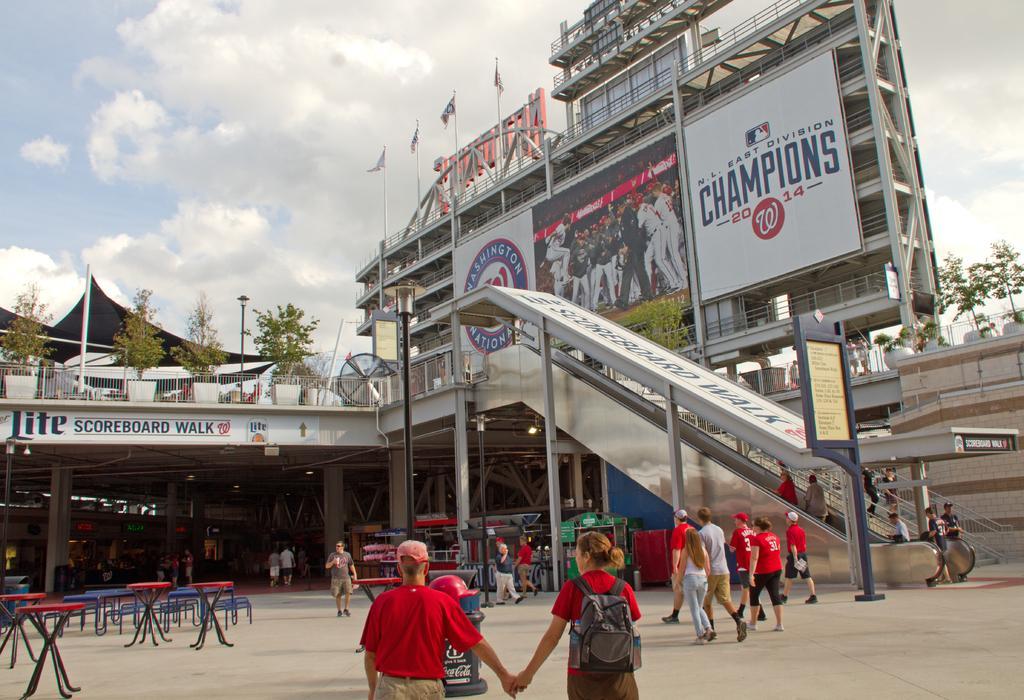How would you summarize this image in a sentence or two? In this picture we can see a group of people walking on the path and in front of the people there is a dustbin and tables and on the right side of the people there is an escalator, poles, trees, hoarding, buildings and a cloudy sky. 